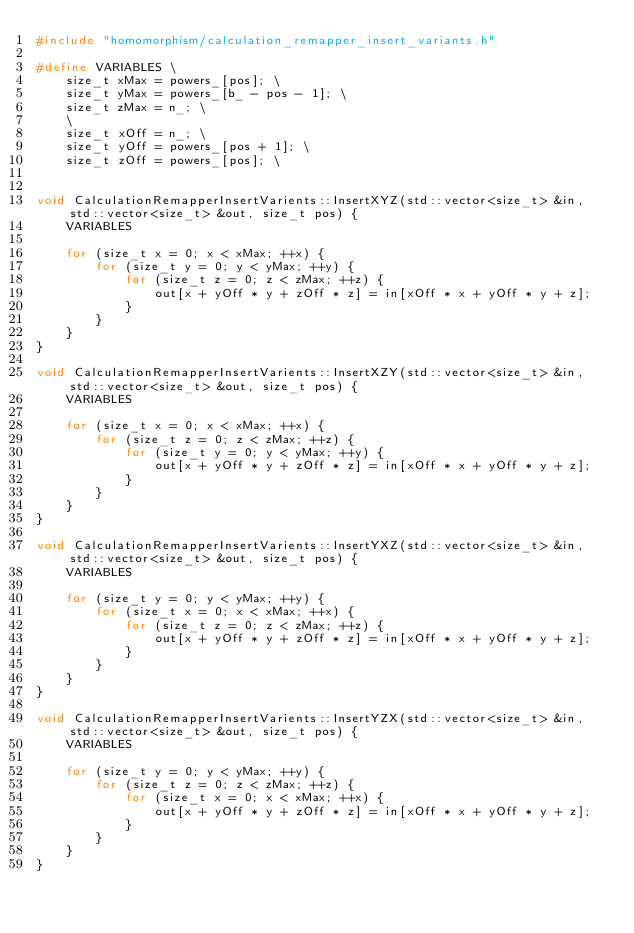Convert code to text. <code><loc_0><loc_0><loc_500><loc_500><_C++_>#include "homomorphism/calculation_remapper_insert_variants.h"

#define VARIABLES \
    size_t xMax = powers_[pos]; \
    size_t yMax = powers_[b_ - pos - 1]; \
    size_t zMax = n_; \
    \
    size_t xOff = n_; \
    size_t yOff = powers_[pos + 1]; \
    size_t zOff = powers_[pos]; \


void CalculationRemapperInsertVarients::InsertXYZ(std::vector<size_t> &in, std::vector<size_t> &out, size_t pos) {
    VARIABLES

    for (size_t x = 0; x < xMax; ++x) {
        for (size_t y = 0; y < yMax; ++y) {
            for (size_t z = 0; z < zMax; ++z) {
                out[x + yOff * y + zOff * z] = in[xOff * x + yOff * y + z];
            }
        }
    }
}

void CalculationRemapperInsertVarients::InsertXZY(std::vector<size_t> &in, std::vector<size_t> &out, size_t pos) {
    VARIABLES

    for (size_t x = 0; x < xMax; ++x) {
        for (size_t z = 0; z < zMax; ++z) {
            for (size_t y = 0; y < yMax; ++y) {
                out[x + yOff * y + zOff * z] = in[xOff * x + yOff * y + z];
            }
        }
    }
}

void CalculationRemapperInsertVarients::InsertYXZ(std::vector<size_t> &in, std::vector<size_t> &out, size_t pos) {
    VARIABLES

    for (size_t y = 0; y < yMax; ++y) {
        for (size_t x = 0; x < xMax; ++x) {
            for (size_t z = 0; z < zMax; ++z) {
                out[x + yOff * y + zOff * z] = in[xOff * x + yOff * y + z];
            }
        }
    }
}

void CalculationRemapperInsertVarients::InsertYZX(std::vector<size_t> &in, std::vector<size_t> &out, size_t pos) {
    VARIABLES

    for (size_t y = 0; y < yMax; ++y) {
        for (size_t z = 0; z < zMax; ++z) {
            for (size_t x = 0; x < xMax; ++x) {
                out[x + yOff * y + zOff * z] = in[xOff * x + yOff * y + z];
            }
        }
    }
}
</code> 